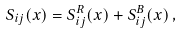Convert formula to latex. <formula><loc_0><loc_0><loc_500><loc_500>S _ { i j } ( x ) = S ^ { R } _ { i j } ( x ) + S ^ { B } _ { i j } ( x ) \, ,</formula> 